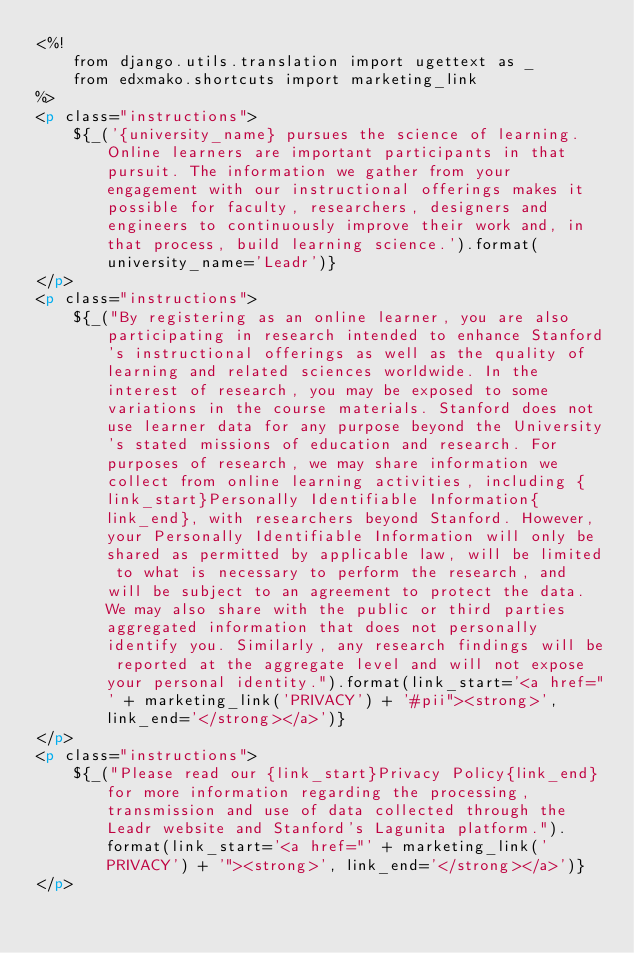<code> <loc_0><loc_0><loc_500><loc_500><_HTML_><%!
    from django.utils.translation import ugettext as _
    from edxmako.shortcuts import marketing_link
%>
<p class="instructions">
    ${_('{university_name} pursues the science of learning. Online learners are important participants in that pursuit. The information we gather from your engagement with our instructional offerings makes it possible for faculty, researchers, designers and engineers to continuously improve their work and, in that process, build learning science.').format(university_name='Leadr')}
</p>
<p class="instructions">
    ${_("By registering as an online learner, you are also participating in research intended to enhance Stanford's instructional offerings as well as the quality of learning and related sciences worldwide. In the interest of research, you may be exposed to some variations in the course materials. Stanford does not use learner data for any purpose beyond the University's stated missions of education and research. For purposes of research, we may share information we collect from online learning activities, including {link_start}Personally Identifiable Information{link_end}, with researchers beyond Stanford. However, your Personally Identifiable Information will only be shared as permitted by applicable law, will be limited to what is necessary to perform the research, and will be subject to an agreement to protect the data. We may also share with the public or third parties aggregated information that does not personally identify you. Similarly, any research findings will be reported at the aggregate level and will not expose your personal identity.").format(link_start='<a href="' + marketing_link('PRIVACY') + '#pii"><strong>', link_end='</strong></a>')}
</p>
<p class="instructions">
    ${_("Please read our {link_start}Privacy Policy{link_end} for more information regarding the processing, transmission and use of data collected through the Leadr website and Stanford's Lagunita platform.").format(link_start='<a href="' + marketing_link('PRIVACY') + '"><strong>', link_end='</strong></a>')}
</p>
</code> 